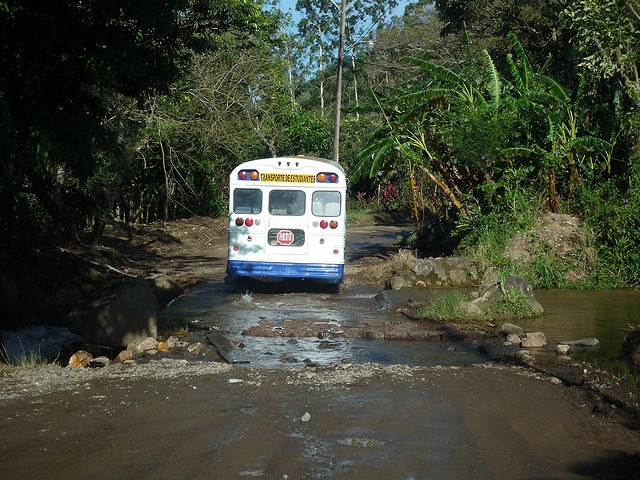Describe the objects in this image and their specific colors. I can see bus in black, white, gray, and darkgray tones and stop sign in black, white, lightpink, salmon, and darkgray tones in this image. 